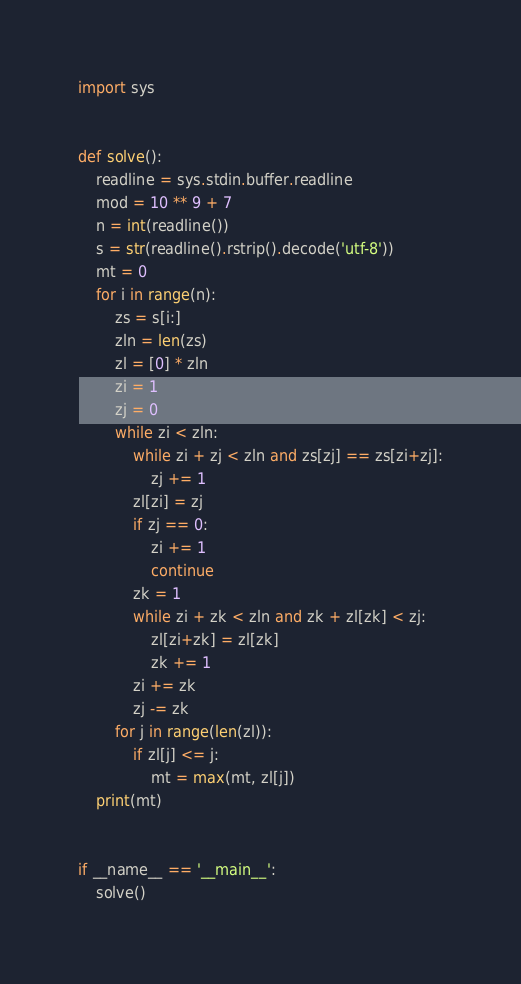Convert code to text. <code><loc_0><loc_0><loc_500><loc_500><_Python_>import sys


def solve():
    readline = sys.stdin.buffer.readline
    mod = 10 ** 9 + 7
    n = int(readline())
    s = str(readline().rstrip().decode('utf-8'))
    mt = 0
    for i in range(n):
        zs = s[i:]
        zln = len(zs)
        zl = [0] * zln
        zi = 1
        zj = 0
        while zi < zln:
            while zi + zj < zln and zs[zj] == zs[zi+zj]:
                zj += 1
            zl[zi] = zj
            if zj == 0:
                zi += 1
                continue
            zk = 1
            while zi + zk < zln and zk + zl[zk] < zj:
                zl[zi+zk] = zl[zk]
                zk += 1
            zi += zk
            zj -= zk
        for j in range(len(zl)):
            if zl[j] <= j:
                mt = max(mt, zl[j])
    print(mt)


if __name__ == '__main__':
    solve()
</code> 